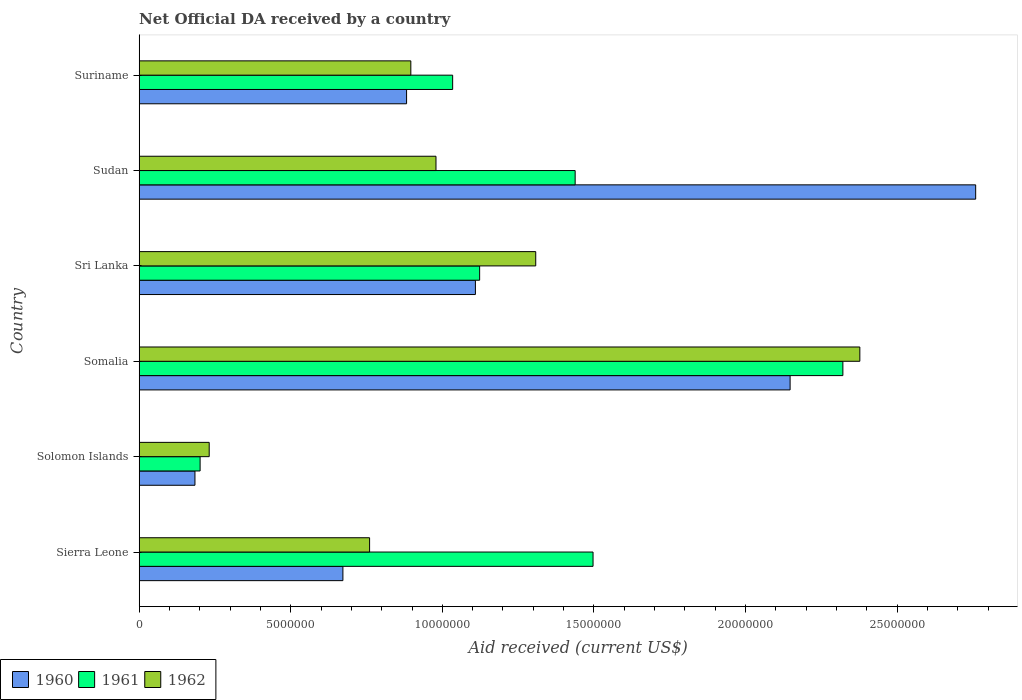Are the number of bars on each tick of the Y-axis equal?
Your answer should be compact. Yes. How many bars are there on the 4th tick from the top?
Provide a succinct answer. 3. How many bars are there on the 3rd tick from the bottom?
Your answer should be very brief. 3. What is the label of the 1st group of bars from the top?
Provide a succinct answer. Suriname. In how many cases, is the number of bars for a given country not equal to the number of legend labels?
Make the answer very short. 0. What is the net official development assistance aid received in 1961 in Sudan?
Ensure brevity in your answer.  1.44e+07. Across all countries, what is the maximum net official development assistance aid received in 1962?
Give a very brief answer. 2.38e+07. Across all countries, what is the minimum net official development assistance aid received in 1961?
Offer a very short reply. 2.01e+06. In which country was the net official development assistance aid received in 1961 maximum?
Offer a terse response. Somalia. In which country was the net official development assistance aid received in 1961 minimum?
Offer a very short reply. Solomon Islands. What is the total net official development assistance aid received in 1960 in the graph?
Your answer should be very brief. 7.75e+07. What is the difference between the net official development assistance aid received in 1960 in Somalia and that in Sudan?
Your answer should be very brief. -6.12e+06. What is the difference between the net official development assistance aid received in 1960 in Sierra Leone and the net official development assistance aid received in 1962 in Sudan?
Give a very brief answer. -3.07e+06. What is the average net official development assistance aid received in 1962 per country?
Offer a very short reply. 1.09e+07. What is the difference between the net official development assistance aid received in 1960 and net official development assistance aid received in 1961 in Solomon Islands?
Provide a short and direct response. -1.70e+05. What is the ratio of the net official development assistance aid received in 1962 in Sierra Leone to that in Sri Lanka?
Keep it short and to the point. 0.58. Is the net official development assistance aid received in 1960 in Solomon Islands less than that in Sri Lanka?
Give a very brief answer. Yes. What is the difference between the highest and the second highest net official development assistance aid received in 1962?
Your answer should be very brief. 1.07e+07. What is the difference between the highest and the lowest net official development assistance aid received in 1962?
Keep it short and to the point. 2.15e+07. What does the 2nd bar from the top in Sierra Leone represents?
Your answer should be very brief. 1961. What does the 2nd bar from the bottom in Sudan represents?
Your answer should be compact. 1961. How many bars are there?
Offer a terse response. 18. How many countries are there in the graph?
Offer a terse response. 6. What is the difference between two consecutive major ticks on the X-axis?
Provide a short and direct response. 5.00e+06. Does the graph contain grids?
Make the answer very short. No. Where does the legend appear in the graph?
Provide a succinct answer. Bottom left. What is the title of the graph?
Your answer should be compact. Net Official DA received by a country. What is the label or title of the X-axis?
Make the answer very short. Aid received (current US$). What is the label or title of the Y-axis?
Provide a short and direct response. Country. What is the Aid received (current US$) in 1960 in Sierra Leone?
Ensure brevity in your answer.  6.72e+06. What is the Aid received (current US$) of 1961 in Sierra Leone?
Provide a succinct answer. 1.50e+07. What is the Aid received (current US$) of 1962 in Sierra Leone?
Keep it short and to the point. 7.60e+06. What is the Aid received (current US$) of 1960 in Solomon Islands?
Offer a terse response. 1.84e+06. What is the Aid received (current US$) of 1961 in Solomon Islands?
Give a very brief answer. 2.01e+06. What is the Aid received (current US$) of 1962 in Solomon Islands?
Give a very brief answer. 2.31e+06. What is the Aid received (current US$) in 1960 in Somalia?
Offer a very short reply. 2.15e+07. What is the Aid received (current US$) of 1961 in Somalia?
Your response must be concise. 2.32e+07. What is the Aid received (current US$) in 1962 in Somalia?
Your response must be concise. 2.38e+07. What is the Aid received (current US$) in 1960 in Sri Lanka?
Provide a short and direct response. 1.11e+07. What is the Aid received (current US$) in 1961 in Sri Lanka?
Ensure brevity in your answer.  1.12e+07. What is the Aid received (current US$) in 1962 in Sri Lanka?
Provide a succinct answer. 1.31e+07. What is the Aid received (current US$) of 1960 in Sudan?
Provide a short and direct response. 2.76e+07. What is the Aid received (current US$) of 1961 in Sudan?
Keep it short and to the point. 1.44e+07. What is the Aid received (current US$) of 1962 in Sudan?
Ensure brevity in your answer.  9.79e+06. What is the Aid received (current US$) in 1960 in Suriname?
Give a very brief answer. 8.82e+06. What is the Aid received (current US$) in 1961 in Suriname?
Offer a terse response. 1.03e+07. What is the Aid received (current US$) of 1962 in Suriname?
Offer a very short reply. 8.96e+06. Across all countries, what is the maximum Aid received (current US$) of 1960?
Give a very brief answer. 2.76e+07. Across all countries, what is the maximum Aid received (current US$) in 1961?
Provide a short and direct response. 2.32e+07. Across all countries, what is the maximum Aid received (current US$) of 1962?
Give a very brief answer. 2.38e+07. Across all countries, what is the minimum Aid received (current US$) of 1960?
Keep it short and to the point. 1.84e+06. Across all countries, what is the minimum Aid received (current US$) in 1961?
Make the answer very short. 2.01e+06. Across all countries, what is the minimum Aid received (current US$) of 1962?
Keep it short and to the point. 2.31e+06. What is the total Aid received (current US$) in 1960 in the graph?
Keep it short and to the point. 7.75e+07. What is the total Aid received (current US$) in 1961 in the graph?
Offer a very short reply. 7.61e+07. What is the total Aid received (current US$) of 1962 in the graph?
Offer a very short reply. 6.55e+07. What is the difference between the Aid received (current US$) of 1960 in Sierra Leone and that in Solomon Islands?
Keep it short and to the point. 4.88e+06. What is the difference between the Aid received (current US$) of 1961 in Sierra Leone and that in Solomon Islands?
Your answer should be very brief. 1.30e+07. What is the difference between the Aid received (current US$) in 1962 in Sierra Leone and that in Solomon Islands?
Keep it short and to the point. 5.29e+06. What is the difference between the Aid received (current US$) in 1960 in Sierra Leone and that in Somalia?
Give a very brief answer. -1.48e+07. What is the difference between the Aid received (current US$) of 1961 in Sierra Leone and that in Somalia?
Give a very brief answer. -8.24e+06. What is the difference between the Aid received (current US$) in 1962 in Sierra Leone and that in Somalia?
Your answer should be compact. -1.62e+07. What is the difference between the Aid received (current US$) of 1960 in Sierra Leone and that in Sri Lanka?
Keep it short and to the point. -4.37e+06. What is the difference between the Aid received (current US$) in 1961 in Sierra Leone and that in Sri Lanka?
Give a very brief answer. 3.74e+06. What is the difference between the Aid received (current US$) of 1962 in Sierra Leone and that in Sri Lanka?
Make the answer very short. -5.48e+06. What is the difference between the Aid received (current US$) of 1960 in Sierra Leone and that in Sudan?
Provide a succinct answer. -2.09e+07. What is the difference between the Aid received (current US$) in 1961 in Sierra Leone and that in Sudan?
Keep it short and to the point. 5.90e+05. What is the difference between the Aid received (current US$) in 1962 in Sierra Leone and that in Sudan?
Offer a terse response. -2.19e+06. What is the difference between the Aid received (current US$) of 1960 in Sierra Leone and that in Suriname?
Your answer should be very brief. -2.10e+06. What is the difference between the Aid received (current US$) in 1961 in Sierra Leone and that in Suriname?
Ensure brevity in your answer.  4.63e+06. What is the difference between the Aid received (current US$) in 1962 in Sierra Leone and that in Suriname?
Make the answer very short. -1.36e+06. What is the difference between the Aid received (current US$) of 1960 in Solomon Islands and that in Somalia?
Your response must be concise. -1.96e+07. What is the difference between the Aid received (current US$) in 1961 in Solomon Islands and that in Somalia?
Provide a succinct answer. -2.12e+07. What is the difference between the Aid received (current US$) in 1962 in Solomon Islands and that in Somalia?
Provide a succinct answer. -2.15e+07. What is the difference between the Aid received (current US$) of 1960 in Solomon Islands and that in Sri Lanka?
Give a very brief answer. -9.25e+06. What is the difference between the Aid received (current US$) of 1961 in Solomon Islands and that in Sri Lanka?
Provide a short and direct response. -9.22e+06. What is the difference between the Aid received (current US$) in 1962 in Solomon Islands and that in Sri Lanka?
Your answer should be compact. -1.08e+07. What is the difference between the Aid received (current US$) in 1960 in Solomon Islands and that in Sudan?
Your answer should be compact. -2.58e+07. What is the difference between the Aid received (current US$) in 1961 in Solomon Islands and that in Sudan?
Give a very brief answer. -1.24e+07. What is the difference between the Aid received (current US$) in 1962 in Solomon Islands and that in Sudan?
Give a very brief answer. -7.48e+06. What is the difference between the Aid received (current US$) in 1960 in Solomon Islands and that in Suriname?
Ensure brevity in your answer.  -6.98e+06. What is the difference between the Aid received (current US$) of 1961 in Solomon Islands and that in Suriname?
Your response must be concise. -8.33e+06. What is the difference between the Aid received (current US$) in 1962 in Solomon Islands and that in Suriname?
Your answer should be compact. -6.65e+06. What is the difference between the Aid received (current US$) in 1960 in Somalia and that in Sri Lanka?
Offer a very short reply. 1.04e+07. What is the difference between the Aid received (current US$) in 1961 in Somalia and that in Sri Lanka?
Keep it short and to the point. 1.20e+07. What is the difference between the Aid received (current US$) of 1962 in Somalia and that in Sri Lanka?
Your response must be concise. 1.07e+07. What is the difference between the Aid received (current US$) in 1960 in Somalia and that in Sudan?
Your answer should be compact. -6.12e+06. What is the difference between the Aid received (current US$) in 1961 in Somalia and that in Sudan?
Your answer should be very brief. 8.83e+06. What is the difference between the Aid received (current US$) in 1962 in Somalia and that in Sudan?
Make the answer very short. 1.40e+07. What is the difference between the Aid received (current US$) in 1960 in Somalia and that in Suriname?
Keep it short and to the point. 1.26e+07. What is the difference between the Aid received (current US$) in 1961 in Somalia and that in Suriname?
Your response must be concise. 1.29e+07. What is the difference between the Aid received (current US$) in 1962 in Somalia and that in Suriname?
Give a very brief answer. 1.48e+07. What is the difference between the Aid received (current US$) in 1960 in Sri Lanka and that in Sudan?
Give a very brief answer. -1.65e+07. What is the difference between the Aid received (current US$) in 1961 in Sri Lanka and that in Sudan?
Offer a terse response. -3.15e+06. What is the difference between the Aid received (current US$) in 1962 in Sri Lanka and that in Sudan?
Your response must be concise. 3.29e+06. What is the difference between the Aid received (current US$) in 1960 in Sri Lanka and that in Suriname?
Make the answer very short. 2.27e+06. What is the difference between the Aid received (current US$) of 1961 in Sri Lanka and that in Suriname?
Keep it short and to the point. 8.90e+05. What is the difference between the Aid received (current US$) in 1962 in Sri Lanka and that in Suriname?
Ensure brevity in your answer.  4.12e+06. What is the difference between the Aid received (current US$) in 1960 in Sudan and that in Suriname?
Keep it short and to the point. 1.88e+07. What is the difference between the Aid received (current US$) of 1961 in Sudan and that in Suriname?
Keep it short and to the point. 4.04e+06. What is the difference between the Aid received (current US$) of 1962 in Sudan and that in Suriname?
Ensure brevity in your answer.  8.30e+05. What is the difference between the Aid received (current US$) of 1960 in Sierra Leone and the Aid received (current US$) of 1961 in Solomon Islands?
Your response must be concise. 4.71e+06. What is the difference between the Aid received (current US$) of 1960 in Sierra Leone and the Aid received (current US$) of 1962 in Solomon Islands?
Your answer should be compact. 4.41e+06. What is the difference between the Aid received (current US$) of 1961 in Sierra Leone and the Aid received (current US$) of 1962 in Solomon Islands?
Provide a short and direct response. 1.27e+07. What is the difference between the Aid received (current US$) of 1960 in Sierra Leone and the Aid received (current US$) of 1961 in Somalia?
Keep it short and to the point. -1.65e+07. What is the difference between the Aid received (current US$) of 1960 in Sierra Leone and the Aid received (current US$) of 1962 in Somalia?
Offer a very short reply. -1.70e+07. What is the difference between the Aid received (current US$) in 1961 in Sierra Leone and the Aid received (current US$) in 1962 in Somalia?
Ensure brevity in your answer.  -8.80e+06. What is the difference between the Aid received (current US$) of 1960 in Sierra Leone and the Aid received (current US$) of 1961 in Sri Lanka?
Offer a very short reply. -4.51e+06. What is the difference between the Aid received (current US$) of 1960 in Sierra Leone and the Aid received (current US$) of 1962 in Sri Lanka?
Keep it short and to the point. -6.36e+06. What is the difference between the Aid received (current US$) of 1961 in Sierra Leone and the Aid received (current US$) of 1962 in Sri Lanka?
Provide a succinct answer. 1.89e+06. What is the difference between the Aid received (current US$) in 1960 in Sierra Leone and the Aid received (current US$) in 1961 in Sudan?
Provide a short and direct response. -7.66e+06. What is the difference between the Aid received (current US$) in 1960 in Sierra Leone and the Aid received (current US$) in 1962 in Sudan?
Your answer should be very brief. -3.07e+06. What is the difference between the Aid received (current US$) of 1961 in Sierra Leone and the Aid received (current US$) of 1962 in Sudan?
Offer a terse response. 5.18e+06. What is the difference between the Aid received (current US$) of 1960 in Sierra Leone and the Aid received (current US$) of 1961 in Suriname?
Offer a very short reply. -3.62e+06. What is the difference between the Aid received (current US$) in 1960 in Sierra Leone and the Aid received (current US$) in 1962 in Suriname?
Offer a very short reply. -2.24e+06. What is the difference between the Aid received (current US$) in 1961 in Sierra Leone and the Aid received (current US$) in 1962 in Suriname?
Provide a succinct answer. 6.01e+06. What is the difference between the Aid received (current US$) of 1960 in Solomon Islands and the Aid received (current US$) of 1961 in Somalia?
Ensure brevity in your answer.  -2.14e+07. What is the difference between the Aid received (current US$) in 1960 in Solomon Islands and the Aid received (current US$) in 1962 in Somalia?
Your answer should be very brief. -2.19e+07. What is the difference between the Aid received (current US$) of 1961 in Solomon Islands and the Aid received (current US$) of 1962 in Somalia?
Your response must be concise. -2.18e+07. What is the difference between the Aid received (current US$) of 1960 in Solomon Islands and the Aid received (current US$) of 1961 in Sri Lanka?
Ensure brevity in your answer.  -9.39e+06. What is the difference between the Aid received (current US$) of 1960 in Solomon Islands and the Aid received (current US$) of 1962 in Sri Lanka?
Your response must be concise. -1.12e+07. What is the difference between the Aid received (current US$) in 1961 in Solomon Islands and the Aid received (current US$) in 1962 in Sri Lanka?
Make the answer very short. -1.11e+07. What is the difference between the Aid received (current US$) in 1960 in Solomon Islands and the Aid received (current US$) in 1961 in Sudan?
Your answer should be very brief. -1.25e+07. What is the difference between the Aid received (current US$) in 1960 in Solomon Islands and the Aid received (current US$) in 1962 in Sudan?
Your answer should be very brief. -7.95e+06. What is the difference between the Aid received (current US$) in 1961 in Solomon Islands and the Aid received (current US$) in 1962 in Sudan?
Provide a succinct answer. -7.78e+06. What is the difference between the Aid received (current US$) of 1960 in Solomon Islands and the Aid received (current US$) of 1961 in Suriname?
Your answer should be very brief. -8.50e+06. What is the difference between the Aid received (current US$) of 1960 in Solomon Islands and the Aid received (current US$) of 1962 in Suriname?
Offer a terse response. -7.12e+06. What is the difference between the Aid received (current US$) of 1961 in Solomon Islands and the Aid received (current US$) of 1962 in Suriname?
Give a very brief answer. -6.95e+06. What is the difference between the Aid received (current US$) of 1960 in Somalia and the Aid received (current US$) of 1961 in Sri Lanka?
Your answer should be very brief. 1.02e+07. What is the difference between the Aid received (current US$) in 1960 in Somalia and the Aid received (current US$) in 1962 in Sri Lanka?
Offer a very short reply. 8.39e+06. What is the difference between the Aid received (current US$) of 1961 in Somalia and the Aid received (current US$) of 1962 in Sri Lanka?
Ensure brevity in your answer.  1.01e+07. What is the difference between the Aid received (current US$) of 1960 in Somalia and the Aid received (current US$) of 1961 in Sudan?
Keep it short and to the point. 7.09e+06. What is the difference between the Aid received (current US$) in 1960 in Somalia and the Aid received (current US$) in 1962 in Sudan?
Provide a succinct answer. 1.17e+07. What is the difference between the Aid received (current US$) in 1961 in Somalia and the Aid received (current US$) in 1962 in Sudan?
Your response must be concise. 1.34e+07. What is the difference between the Aid received (current US$) in 1960 in Somalia and the Aid received (current US$) in 1961 in Suriname?
Keep it short and to the point. 1.11e+07. What is the difference between the Aid received (current US$) in 1960 in Somalia and the Aid received (current US$) in 1962 in Suriname?
Ensure brevity in your answer.  1.25e+07. What is the difference between the Aid received (current US$) in 1961 in Somalia and the Aid received (current US$) in 1962 in Suriname?
Provide a short and direct response. 1.42e+07. What is the difference between the Aid received (current US$) of 1960 in Sri Lanka and the Aid received (current US$) of 1961 in Sudan?
Your response must be concise. -3.29e+06. What is the difference between the Aid received (current US$) of 1960 in Sri Lanka and the Aid received (current US$) of 1962 in Sudan?
Keep it short and to the point. 1.30e+06. What is the difference between the Aid received (current US$) of 1961 in Sri Lanka and the Aid received (current US$) of 1962 in Sudan?
Your response must be concise. 1.44e+06. What is the difference between the Aid received (current US$) of 1960 in Sri Lanka and the Aid received (current US$) of 1961 in Suriname?
Provide a succinct answer. 7.50e+05. What is the difference between the Aid received (current US$) of 1960 in Sri Lanka and the Aid received (current US$) of 1962 in Suriname?
Keep it short and to the point. 2.13e+06. What is the difference between the Aid received (current US$) of 1961 in Sri Lanka and the Aid received (current US$) of 1962 in Suriname?
Keep it short and to the point. 2.27e+06. What is the difference between the Aid received (current US$) of 1960 in Sudan and the Aid received (current US$) of 1961 in Suriname?
Your answer should be very brief. 1.72e+07. What is the difference between the Aid received (current US$) of 1960 in Sudan and the Aid received (current US$) of 1962 in Suriname?
Make the answer very short. 1.86e+07. What is the difference between the Aid received (current US$) in 1961 in Sudan and the Aid received (current US$) in 1962 in Suriname?
Keep it short and to the point. 5.42e+06. What is the average Aid received (current US$) of 1960 per country?
Give a very brief answer. 1.29e+07. What is the average Aid received (current US$) in 1961 per country?
Your answer should be very brief. 1.27e+07. What is the average Aid received (current US$) of 1962 per country?
Your answer should be very brief. 1.09e+07. What is the difference between the Aid received (current US$) in 1960 and Aid received (current US$) in 1961 in Sierra Leone?
Your answer should be compact. -8.25e+06. What is the difference between the Aid received (current US$) of 1960 and Aid received (current US$) of 1962 in Sierra Leone?
Ensure brevity in your answer.  -8.80e+05. What is the difference between the Aid received (current US$) in 1961 and Aid received (current US$) in 1962 in Sierra Leone?
Give a very brief answer. 7.37e+06. What is the difference between the Aid received (current US$) in 1960 and Aid received (current US$) in 1962 in Solomon Islands?
Offer a very short reply. -4.70e+05. What is the difference between the Aid received (current US$) of 1961 and Aid received (current US$) of 1962 in Solomon Islands?
Make the answer very short. -3.00e+05. What is the difference between the Aid received (current US$) of 1960 and Aid received (current US$) of 1961 in Somalia?
Provide a succinct answer. -1.74e+06. What is the difference between the Aid received (current US$) of 1960 and Aid received (current US$) of 1962 in Somalia?
Offer a terse response. -2.30e+06. What is the difference between the Aid received (current US$) in 1961 and Aid received (current US$) in 1962 in Somalia?
Keep it short and to the point. -5.60e+05. What is the difference between the Aid received (current US$) in 1960 and Aid received (current US$) in 1962 in Sri Lanka?
Your response must be concise. -1.99e+06. What is the difference between the Aid received (current US$) of 1961 and Aid received (current US$) of 1962 in Sri Lanka?
Offer a very short reply. -1.85e+06. What is the difference between the Aid received (current US$) in 1960 and Aid received (current US$) in 1961 in Sudan?
Your answer should be compact. 1.32e+07. What is the difference between the Aid received (current US$) of 1960 and Aid received (current US$) of 1962 in Sudan?
Provide a succinct answer. 1.78e+07. What is the difference between the Aid received (current US$) in 1961 and Aid received (current US$) in 1962 in Sudan?
Offer a terse response. 4.59e+06. What is the difference between the Aid received (current US$) in 1960 and Aid received (current US$) in 1961 in Suriname?
Give a very brief answer. -1.52e+06. What is the difference between the Aid received (current US$) of 1961 and Aid received (current US$) of 1962 in Suriname?
Offer a very short reply. 1.38e+06. What is the ratio of the Aid received (current US$) of 1960 in Sierra Leone to that in Solomon Islands?
Your response must be concise. 3.65. What is the ratio of the Aid received (current US$) of 1961 in Sierra Leone to that in Solomon Islands?
Offer a very short reply. 7.45. What is the ratio of the Aid received (current US$) in 1962 in Sierra Leone to that in Solomon Islands?
Your response must be concise. 3.29. What is the ratio of the Aid received (current US$) in 1960 in Sierra Leone to that in Somalia?
Keep it short and to the point. 0.31. What is the ratio of the Aid received (current US$) in 1961 in Sierra Leone to that in Somalia?
Offer a very short reply. 0.65. What is the ratio of the Aid received (current US$) in 1962 in Sierra Leone to that in Somalia?
Your answer should be very brief. 0.32. What is the ratio of the Aid received (current US$) in 1960 in Sierra Leone to that in Sri Lanka?
Your answer should be compact. 0.61. What is the ratio of the Aid received (current US$) in 1961 in Sierra Leone to that in Sri Lanka?
Your answer should be very brief. 1.33. What is the ratio of the Aid received (current US$) in 1962 in Sierra Leone to that in Sri Lanka?
Provide a short and direct response. 0.58. What is the ratio of the Aid received (current US$) in 1960 in Sierra Leone to that in Sudan?
Offer a terse response. 0.24. What is the ratio of the Aid received (current US$) of 1961 in Sierra Leone to that in Sudan?
Provide a short and direct response. 1.04. What is the ratio of the Aid received (current US$) in 1962 in Sierra Leone to that in Sudan?
Offer a terse response. 0.78. What is the ratio of the Aid received (current US$) in 1960 in Sierra Leone to that in Suriname?
Give a very brief answer. 0.76. What is the ratio of the Aid received (current US$) of 1961 in Sierra Leone to that in Suriname?
Provide a succinct answer. 1.45. What is the ratio of the Aid received (current US$) of 1962 in Sierra Leone to that in Suriname?
Make the answer very short. 0.85. What is the ratio of the Aid received (current US$) in 1960 in Solomon Islands to that in Somalia?
Provide a succinct answer. 0.09. What is the ratio of the Aid received (current US$) in 1961 in Solomon Islands to that in Somalia?
Offer a very short reply. 0.09. What is the ratio of the Aid received (current US$) in 1962 in Solomon Islands to that in Somalia?
Offer a terse response. 0.1. What is the ratio of the Aid received (current US$) in 1960 in Solomon Islands to that in Sri Lanka?
Provide a succinct answer. 0.17. What is the ratio of the Aid received (current US$) in 1961 in Solomon Islands to that in Sri Lanka?
Your response must be concise. 0.18. What is the ratio of the Aid received (current US$) in 1962 in Solomon Islands to that in Sri Lanka?
Provide a succinct answer. 0.18. What is the ratio of the Aid received (current US$) in 1960 in Solomon Islands to that in Sudan?
Your response must be concise. 0.07. What is the ratio of the Aid received (current US$) of 1961 in Solomon Islands to that in Sudan?
Give a very brief answer. 0.14. What is the ratio of the Aid received (current US$) of 1962 in Solomon Islands to that in Sudan?
Offer a very short reply. 0.24. What is the ratio of the Aid received (current US$) of 1960 in Solomon Islands to that in Suriname?
Offer a very short reply. 0.21. What is the ratio of the Aid received (current US$) in 1961 in Solomon Islands to that in Suriname?
Make the answer very short. 0.19. What is the ratio of the Aid received (current US$) in 1962 in Solomon Islands to that in Suriname?
Give a very brief answer. 0.26. What is the ratio of the Aid received (current US$) in 1960 in Somalia to that in Sri Lanka?
Provide a short and direct response. 1.94. What is the ratio of the Aid received (current US$) in 1961 in Somalia to that in Sri Lanka?
Make the answer very short. 2.07. What is the ratio of the Aid received (current US$) of 1962 in Somalia to that in Sri Lanka?
Keep it short and to the point. 1.82. What is the ratio of the Aid received (current US$) of 1960 in Somalia to that in Sudan?
Your answer should be very brief. 0.78. What is the ratio of the Aid received (current US$) of 1961 in Somalia to that in Sudan?
Ensure brevity in your answer.  1.61. What is the ratio of the Aid received (current US$) in 1962 in Somalia to that in Sudan?
Provide a succinct answer. 2.43. What is the ratio of the Aid received (current US$) of 1960 in Somalia to that in Suriname?
Give a very brief answer. 2.43. What is the ratio of the Aid received (current US$) in 1961 in Somalia to that in Suriname?
Your answer should be compact. 2.24. What is the ratio of the Aid received (current US$) in 1962 in Somalia to that in Suriname?
Your response must be concise. 2.65. What is the ratio of the Aid received (current US$) in 1960 in Sri Lanka to that in Sudan?
Your response must be concise. 0.4. What is the ratio of the Aid received (current US$) of 1961 in Sri Lanka to that in Sudan?
Make the answer very short. 0.78. What is the ratio of the Aid received (current US$) in 1962 in Sri Lanka to that in Sudan?
Give a very brief answer. 1.34. What is the ratio of the Aid received (current US$) of 1960 in Sri Lanka to that in Suriname?
Give a very brief answer. 1.26. What is the ratio of the Aid received (current US$) of 1961 in Sri Lanka to that in Suriname?
Provide a succinct answer. 1.09. What is the ratio of the Aid received (current US$) of 1962 in Sri Lanka to that in Suriname?
Provide a succinct answer. 1.46. What is the ratio of the Aid received (current US$) of 1960 in Sudan to that in Suriname?
Make the answer very short. 3.13. What is the ratio of the Aid received (current US$) of 1961 in Sudan to that in Suriname?
Your response must be concise. 1.39. What is the ratio of the Aid received (current US$) of 1962 in Sudan to that in Suriname?
Your response must be concise. 1.09. What is the difference between the highest and the second highest Aid received (current US$) in 1960?
Provide a succinct answer. 6.12e+06. What is the difference between the highest and the second highest Aid received (current US$) in 1961?
Keep it short and to the point. 8.24e+06. What is the difference between the highest and the second highest Aid received (current US$) in 1962?
Your answer should be very brief. 1.07e+07. What is the difference between the highest and the lowest Aid received (current US$) of 1960?
Provide a short and direct response. 2.58e+07. What is the difference between the highest and the lowest Aid received (current US$) in 1961?
Offer a very short reply. 2.12e+07. What is the difference between the highest and the lowest Aid received (current US$) of 1962?
Provide a short and direct response. 2.15e+07. 